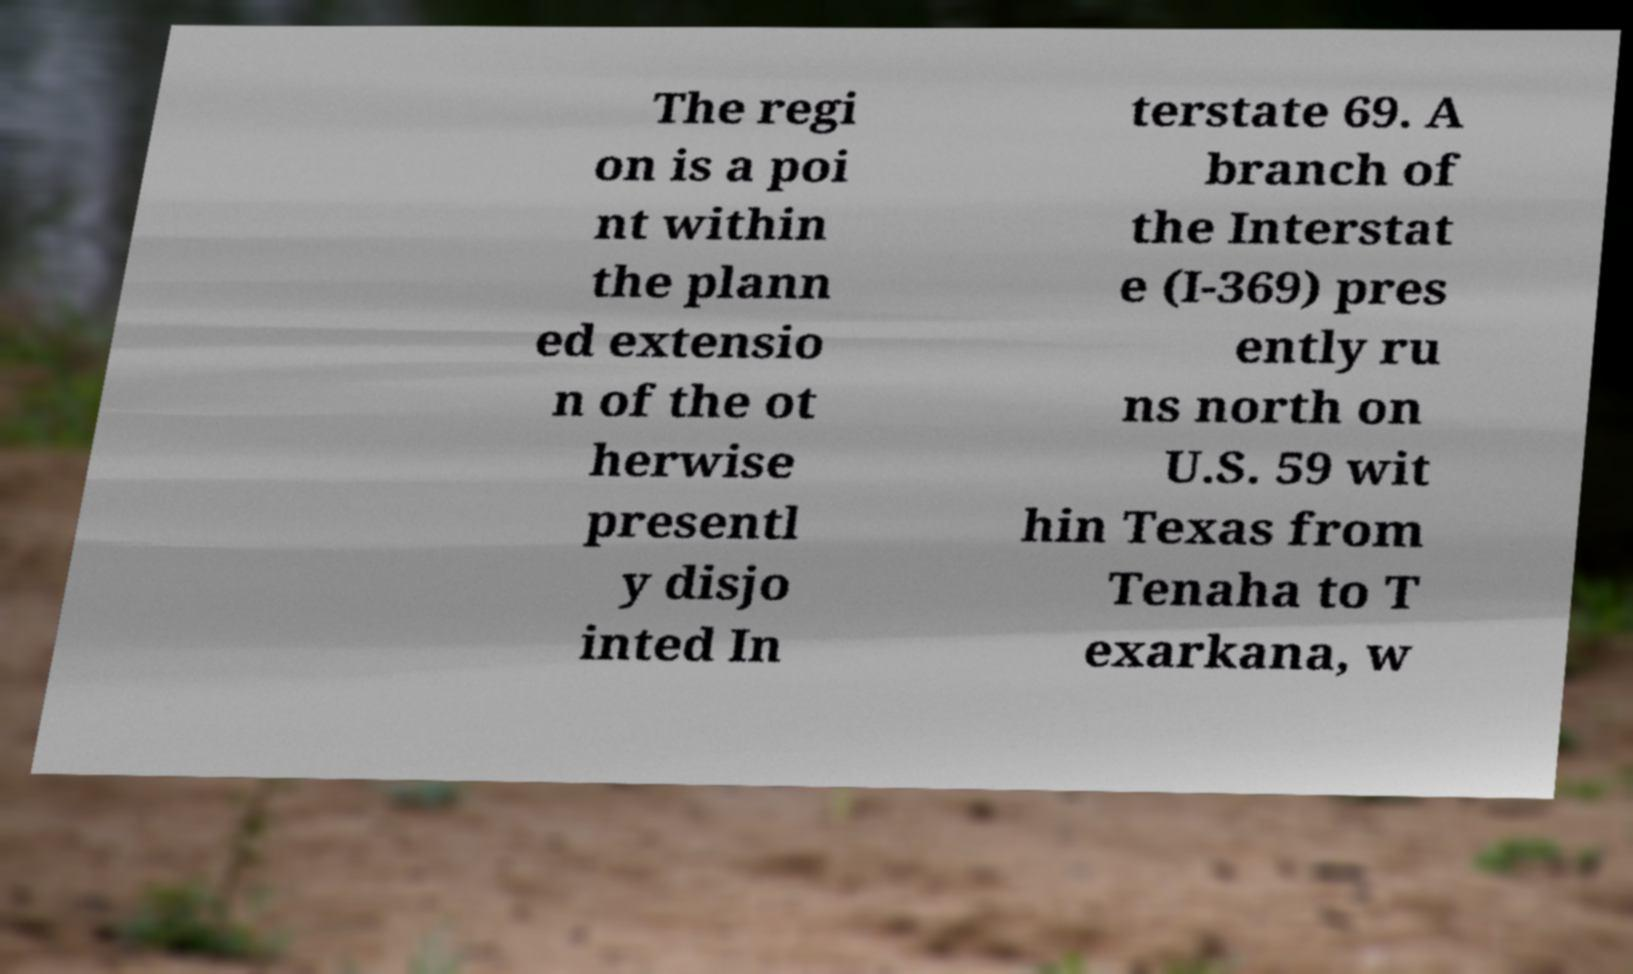For documentation purposes, I need the text within this image transcribed. Could you provide that? The regi on is a poi nt within the plann ed extensio n of the ot herwise presentl y disjo inted In terstate 69. A branch of the Interstat e (I-369) pres ently ru ns north on U.S. 59 wit hin Texas from Tenaha to T exarkana, w 